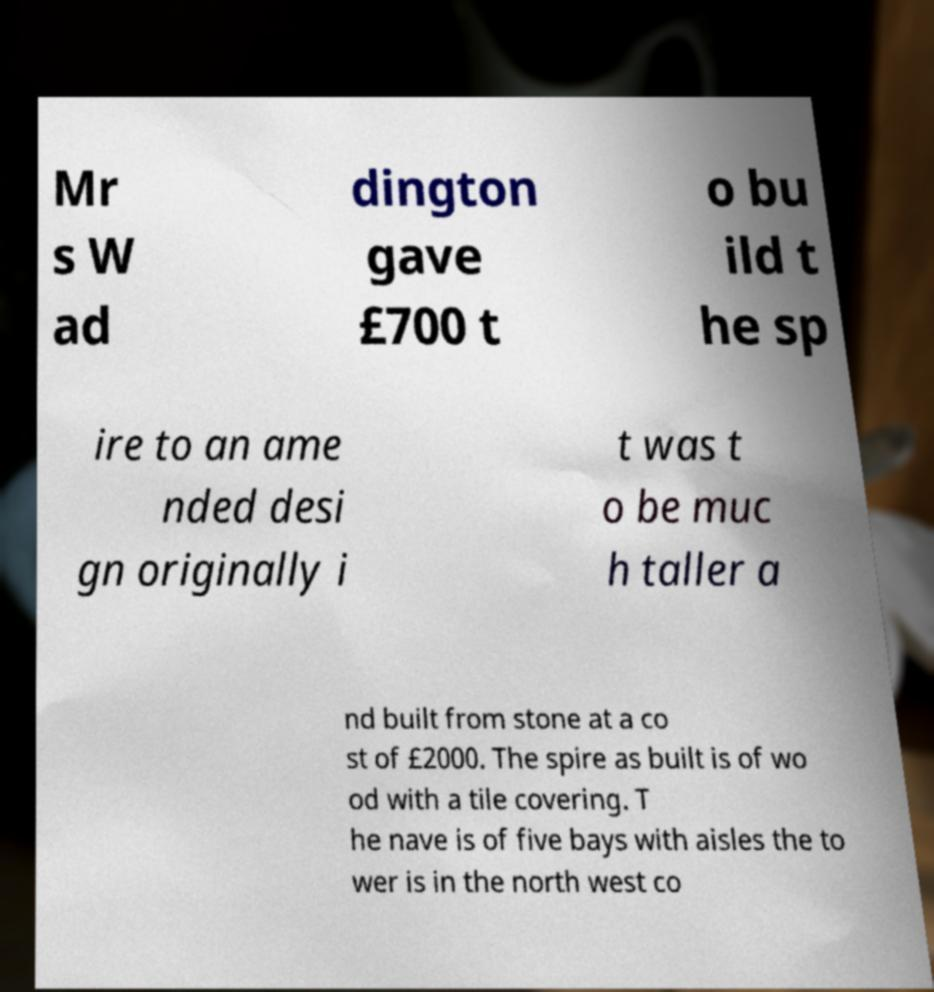Please identify and transcribe the text found in this image. Mr s W ad dington gave £700 t o bu ild t he sp ire to an ame nded desi gn originally i t was t o be muc h taller a nd built from stone at a co st of £2000. The spire as built is of wo od with a tile covering. T he nave is of five bays with aisles the to wer is in the north west co 